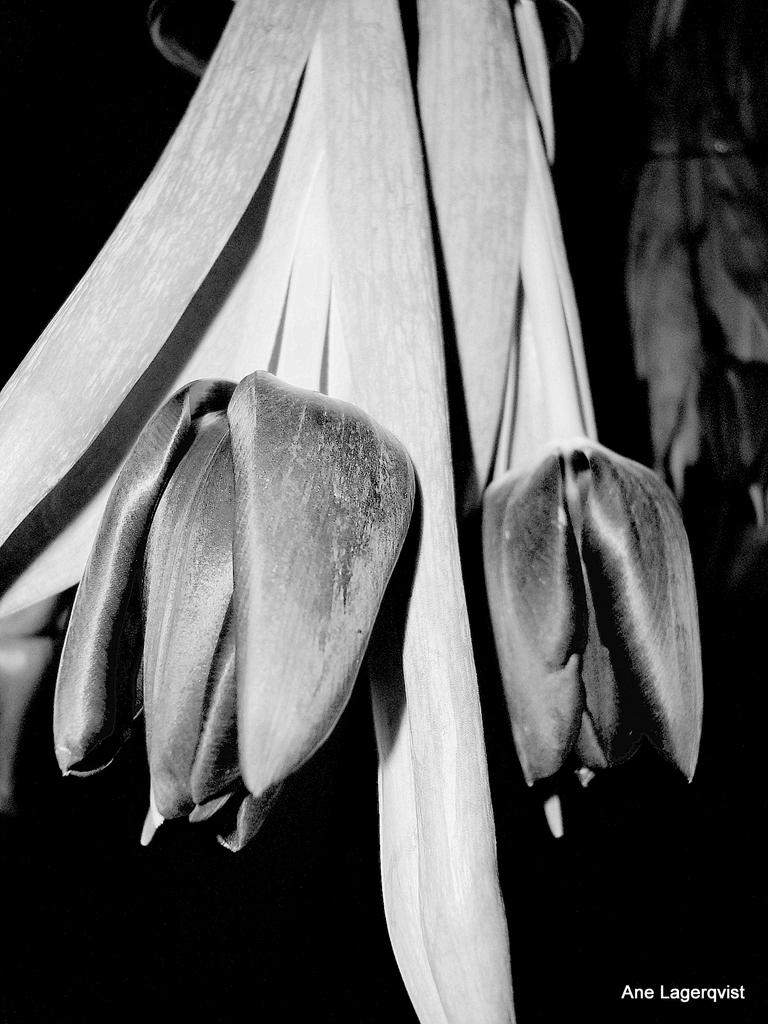What is the color scheme of the image? The image is black and white. What type of plants can be seen in the image? There are flowers and leaves in the image. What type of vegetable is growing on the roof in the image? There is no roof or vegetable present in the image. Who is the achiever in the image? There is no person or achievement depicted in the image. 